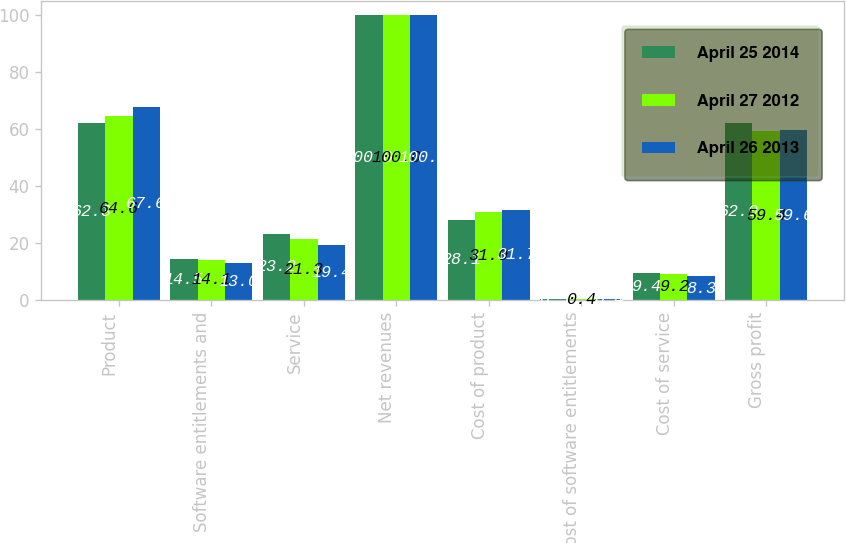Convert chart to OTSL. <chart><loc_0><loc_0><loc_500><loc_500><stacked_bar_chart><ecel><fcel>Product<fcel>Software entitlements and<fcel>Service<fcel>Net revenues<fcel>Cost of product<fcel>Cost of software entitlements<fcel>Cost of service<fcel>Gross profit<nl><fcel>April 25 2014<fcel>62.3<fcel>14.5<fcel>23.2<fcel>100<fcel>28.1<fcel>0.5<fcel>9.4<fcel>62<nl><fcel>April 27 2012<fcel>64.6<fcel>14.1<fcel>21.3<fcel>100<fcel>31<fcel>0.4<fcel>9.2<fcel>59.4<nl><fcel>April 26 2013<fcel>67.6<fcel>13<fcel>19.4<fcel>100<fcel>31.7<fcel>0.4<fcel>8.3<fcel>59.6<nl></chart> 